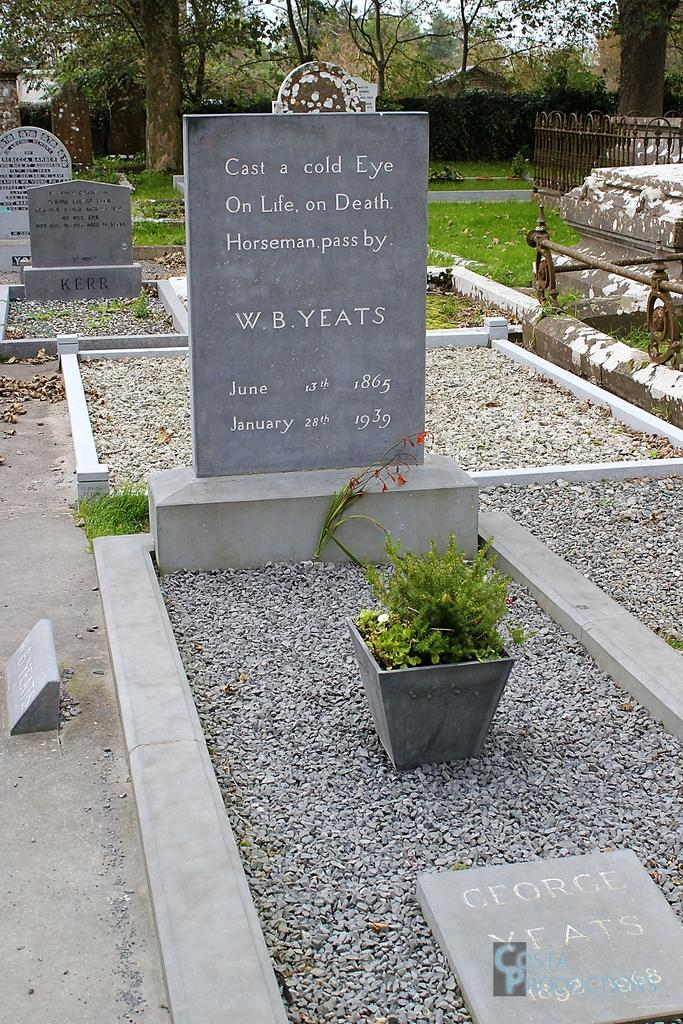What is the main subject of the image? The main subject of the image is a graveyard. What can be seen in the background of the image? In the background of the image, there are plants and trees. What is the secretary's opinion about the heart in the image? There is no secretary or heart present in the image, so it is not possible to determine their opinion. 